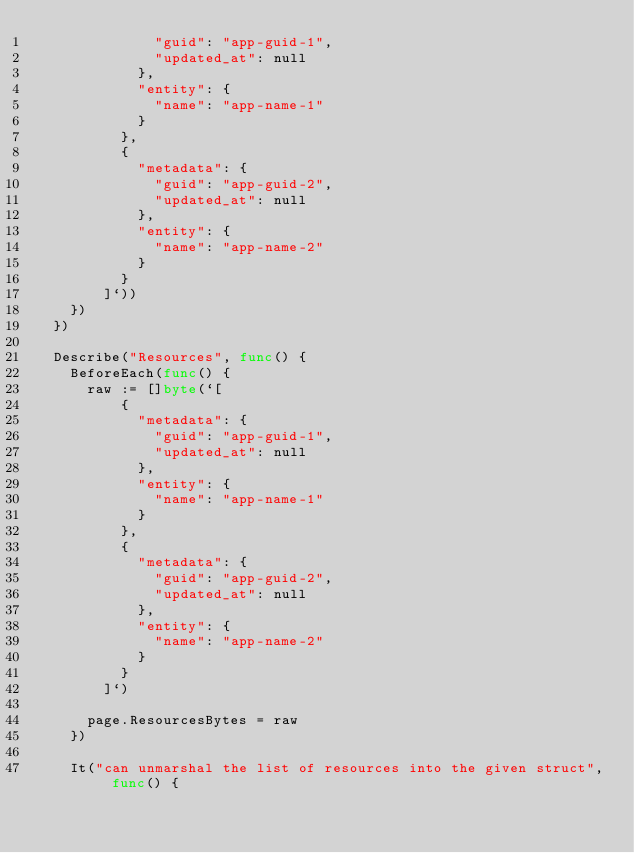<code> <loc_0><loc_0><loc_500><loc_500><_Go_>							"guid": "app-guid-1",
							"updated_at": null
						},
						"entity": {
							"name": "app-name-1"
						}
					},
					{
						"metadata": {
							"guid": "app-guid-2",
							"updated_at": null
						},
						"entity": {
							"name": "app-name-2"
						}
					}
				]`))
		})
	})

	Describe("Resources", func() {
		BeforeEach(func() {
			raw := []byte(`[
					{
						"metadata": {
							"guid": "app-guid-1",
							"updated_at": null
						},
						"entity": {
							"name": "app-name-1"
						}
					},
					{
						"metadata": {
							"guid": "app-guid-2",
							"updated_at": null
						},
						"entity": {
							"name": "app-name-2"
						}
					}
				]`)

			page.ResourcesBytes = raw
		})

		It("can unmarshal the list of resources into the given struct", func() {</code> 